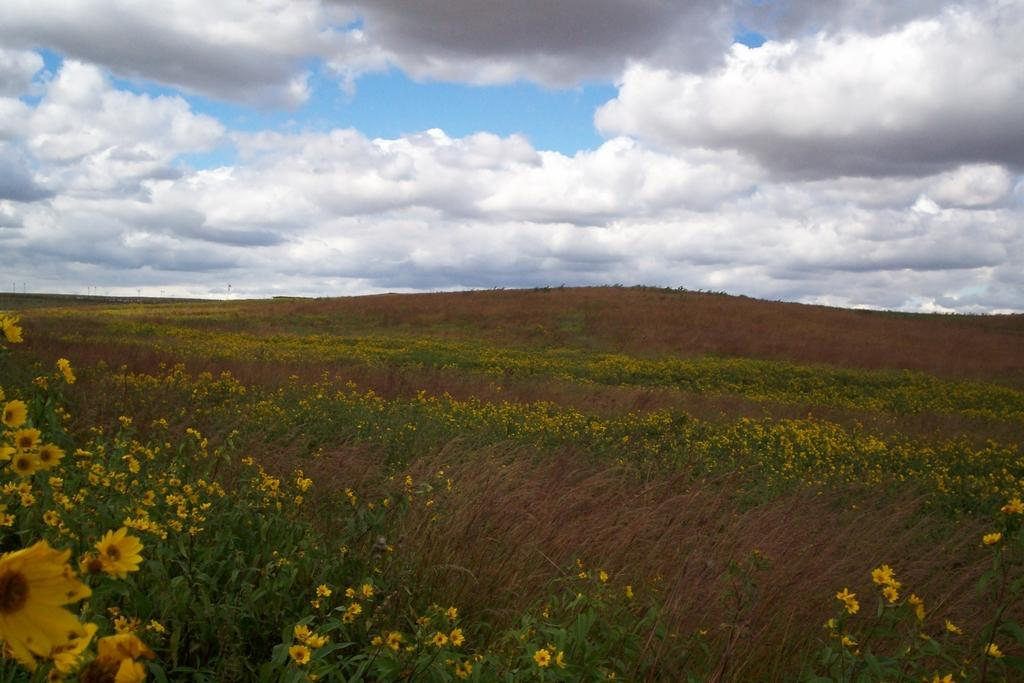What type of flowers can be seen at the bottom of the image? There is a field of yellow color flowers at the bottom of the image. What is the condition of the sky in the image? The sky is cloudy at the top of the image. Where can the cherries be found in the image? There are no cherries present in the image. Is there any indication of an attack happening in the image? There is no indication of an attack in the image; it features a field of yellow flowers and a cloudy sky. 